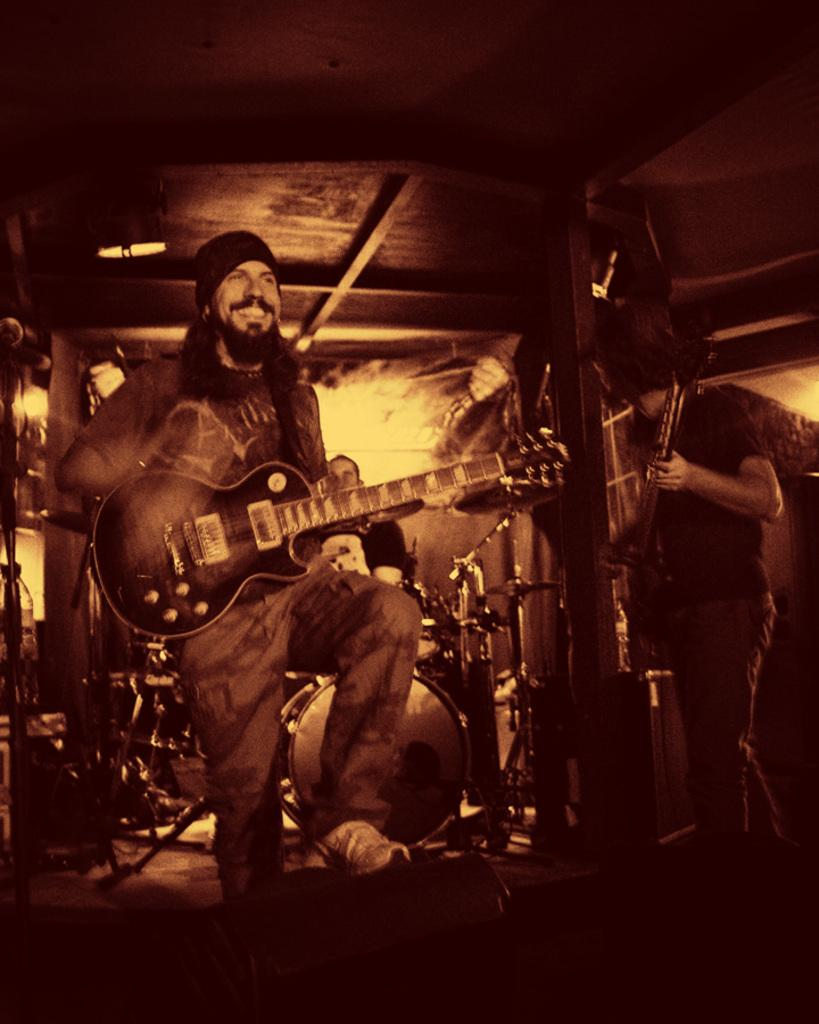What is the person in the image holding? The person is holding a guitar. Can you describe the other people in the image? The other persons in the background are holding musical instruments. What else can be seen in the background of the image? There are additional musical instruments visible in the background. What type of flesh can be seen on the mountain in the image? There is no mountain or flesh present in the image. 